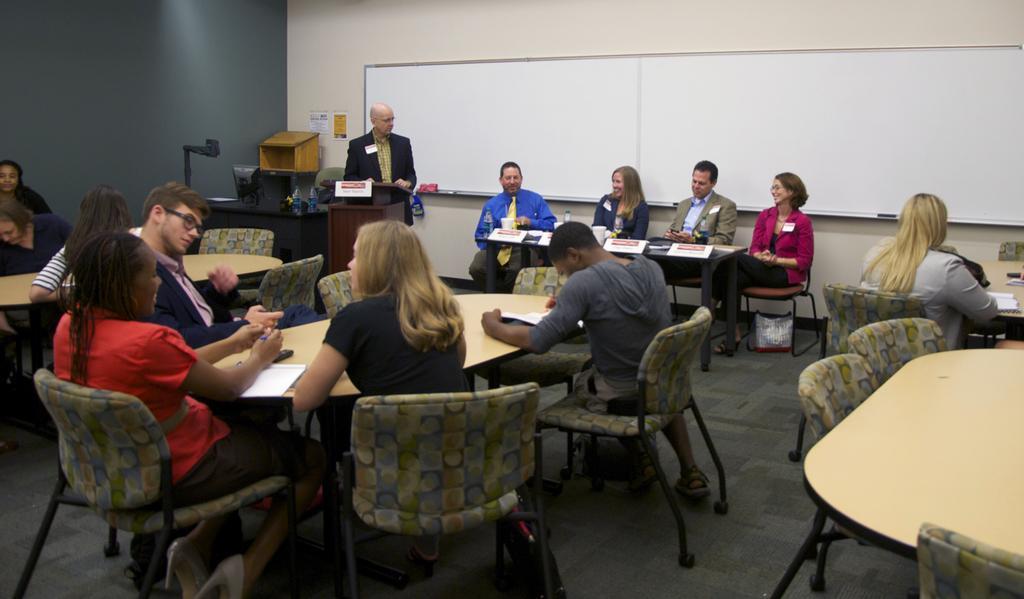In one or two sentences, can you explain what this image depicts? Here we can see a group of people sitting on chairs in front of table and here there panel of four these are also sitting in front of table on chairs and here is a guy standing near a speech desk and behind them we can see a white board 